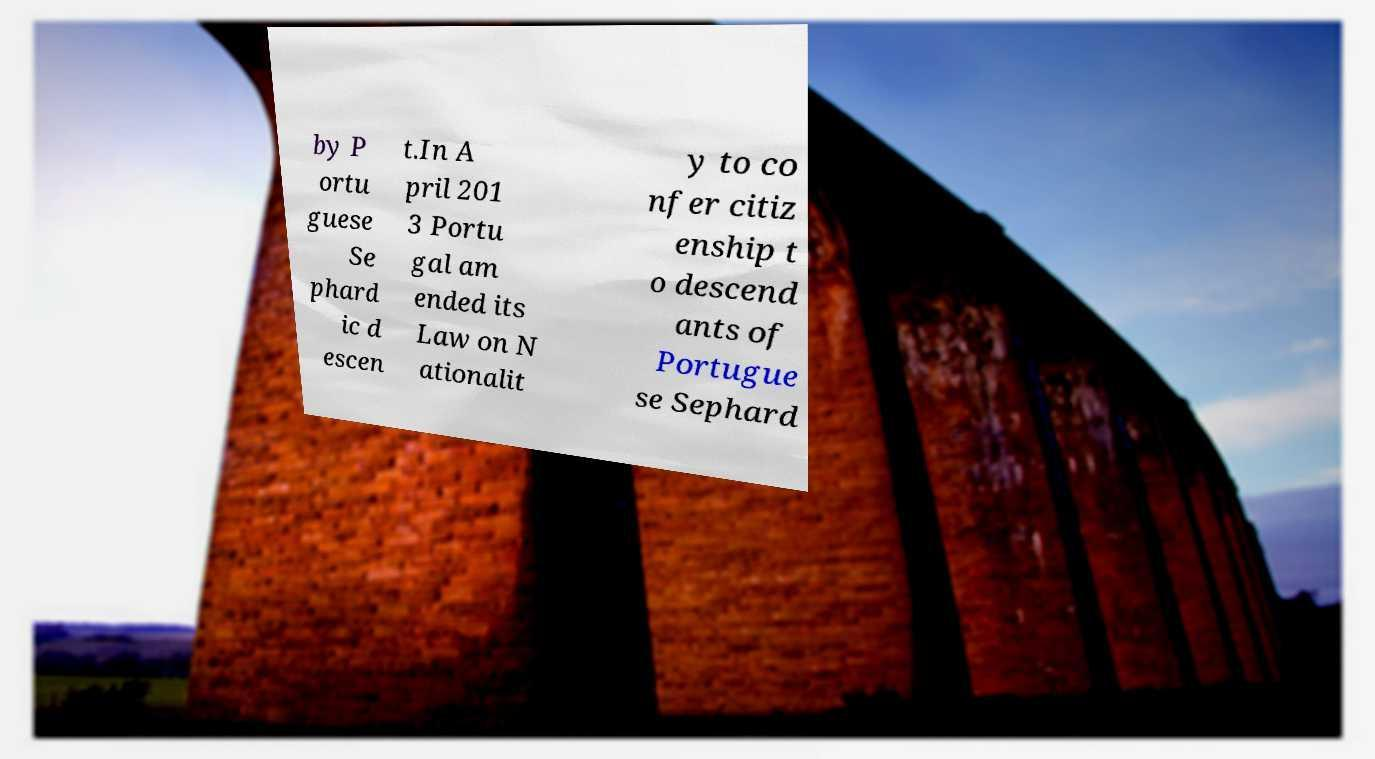Please identify and transcribe the text found in this image. by P ortu guese Se phard ic d escen t.In A pril 201 3 Portu gal am ended its Law on N ationalit y to co nfer citiz enship t o descend ants of Portugue se Sephard 